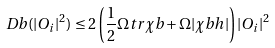Convert formula to latex. <formula><loc_0><loc_0><loc_500><loc_500>\ D b ( | O _ { i } | ^ { 2 } ) \leq 2 \left ( \frac { 1 } { 2 } \Omega t r \chi b + \Omega | \chi b h | \right ) | O _ { i } | ^ { 2 }</formula> 